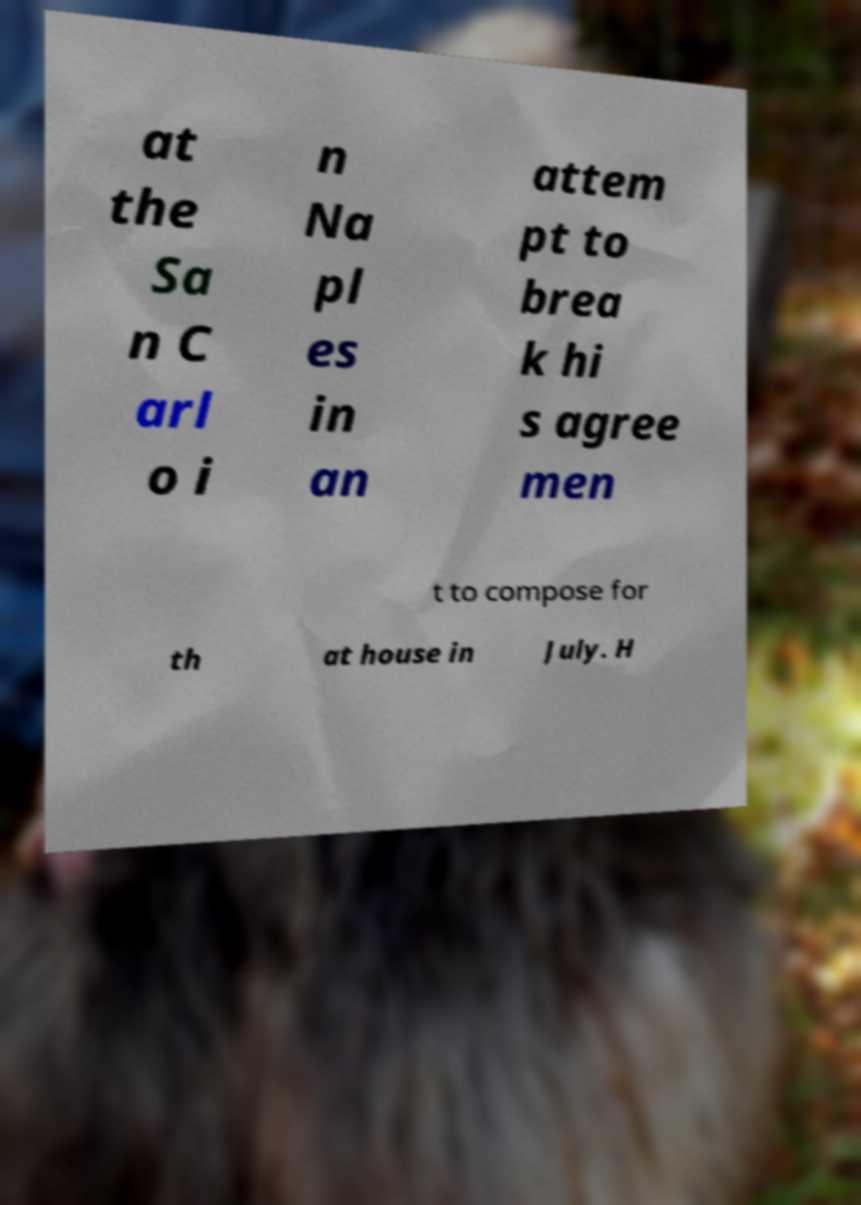Can you accurately transcribe the text from the provided image for me? at the Sa n C arl o i n Na pl es in an attem pt to brea k hi s agree men t to compose for th at house in July. H 